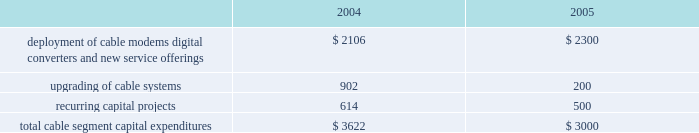Management 2019s discussion and analysis of financial condition and results of operations comcast corporation and subsidiaries28 comcast corporation and subsidiaries the exchangeable notes varies based upon the fair market value of the security to which it is indexed .
The exchangeable notes are collateralized by our investments in cablevision , microsoft and vodafone , respectively .
The comcast exchangeable notes are collateralized by our class a special common stock held in treasury .
We have settled and intend in the future to settle all of the comcast exchangeable notes using cash .
During 2004 and 2003 , we settled an aggregate of $ 847 million face amount and $ 638 million face amount , respectively , of our obligations relating to our notes exchangeable into comcast stock by delivering cash to the counterparty upon maturity of the instruments , and the equity collar agreements related to the underlying shares expired or were settled .
During 2004 and 2003 , we settled $ 2.359 billion face amount and $ 1.213 billion face amount , respectively , of our obligations relating to our exchangeable notes by delivering the underlying shares of common stock to the counterparty upon maturity of the investments .
As of december 31 , 2004 , our debt includes an aggregate of $ 1.699 billion of exchangeable notes , including $ 1.645 billion within current portion of long-term debt .
As of december 31 , 2004 , the securities we hold collateralizing the exchangeable notes were sufficient to substantially satisfy the debt obligations associated with the outstanding exchangeable notes .
Stock repurchases .
During 2004 , under our board-authorized , $ 2 billion share repurchase program , we repurchased 46.9 million shares of our class a special common stock for $ 1.328 billion .
We expect such repurchases to continue from time to time in the open market or in private transactions , subject to market conditions .
Refer to notes 8 and 10 to our consolidated financial statements for a discussion of our financing activities .
Investing activities net cash used in investing activities from continuing operations was $ 4.512 billion for the year ended december 31 , 2004 , and consists primarily of capital expenditures of $ 3.660 billion , additions to intangible and other noncurrent assets of $ 628 million and the acquisition of techtv for approximately $ 300 million .
Capital expenditures .
Our most significant recurring investing activity has been and is expected to continue to be capital expendi- tures .
The table illustrates the capital expenditures we incurred in our cable segment during 2004 and expect to incur in 2005 ( dollars in millions ) : .
The amount of our capital expenditures for 2005 and for subsequent years will depend on numerous factors , some of which are beyond our control , including competition , changes in technology and the timing and rate of deployment of new services .
Additions to intangibles .
Additions to intangibles during 2004 primarily relate to our investment in a $ 250 million long-term strategic license agreement with gemstar , multiple dwelling unit contracts of approximately $ 133 million and other licenses and software intangibles of approximately $ 168 million .
Investments .
Proceeds from sales , settlements and restructurings of investments totaled $ 228 million during 2004 , related to the sales of our non-strategic investments , including our 20% ( 20 % ) interest in dhc ventures , llc ( discovery health channel ) for approximately $ 149 million .
We consider investments that we determine to be non-strategic , highly-valued , or both to be a source of liquidity .
We consider our investment in $ 1.5 billion in time warner common-equivalent preferred stock to be an anticipated source of liquidity .
We do not have any significant contractual funding commitments with respect to any of our investments .
Refer to notes 6 and 7 to our consolidated financial statements for a discussion of our investments and our intangible assets , respectively .
Off-balance sheet arrangements we do not have any significant off-balance sheet arrangements that are reasonably likely to have a current or future effect on our financial condition , results of operations , liquidity , capital expenditures or capital resources. .
What percentage of total cable segment capital expenditures in 2004 where due to upgrading of cable systems? 
Computations: (902 / 3622)
Answer: 0.24903. 